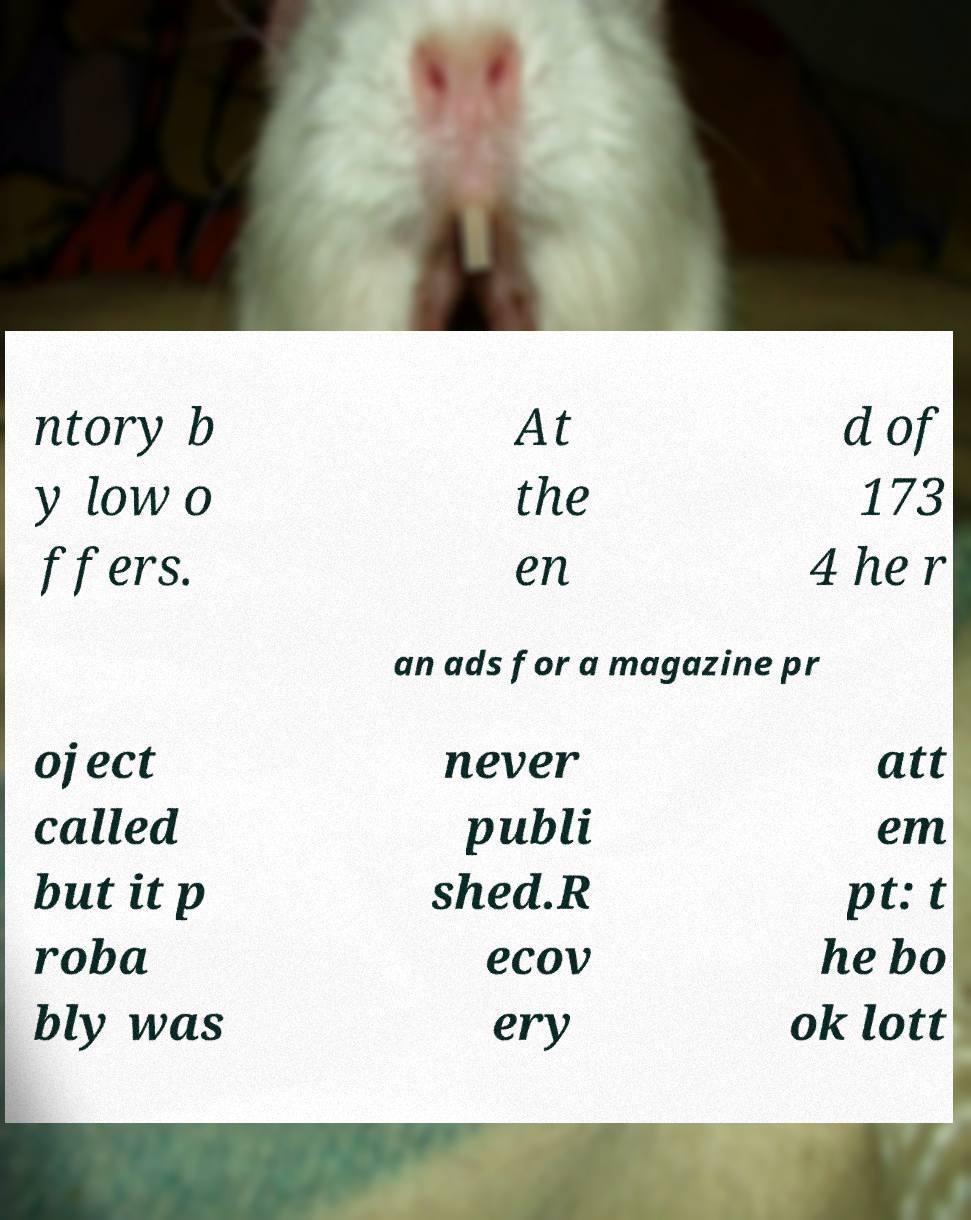What messages or text are displayed in this image? I need them in a readable, typed format. ntory b y low o ffers. At the en d of 173 4 he r an ads for a magazine pr oject called but it p roba bly was never publi shed.R ecov ery att em pt: t he bo ok lott 